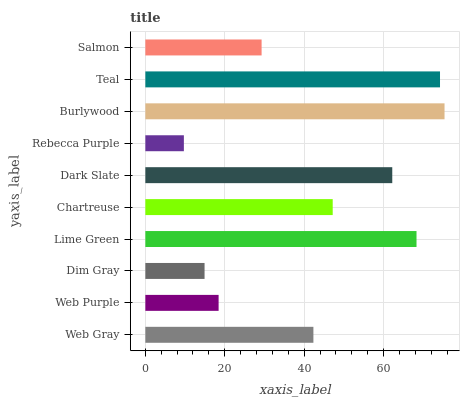Is Rebecca Purple the minimum?
Answer yes or no. Yes. Is Burlywood the maximum?
Answer yes or no. Yes. Is Web Purple the minimum?
Answer yes or no. No. Is Web Purple the maximum?
Answer yes or no. No. Is Web Gray greater than Web Purple?
Answer yes or no. Yes. Is Web Purple less than Web Gray?
Answer yes or no. Yes. Is Web Purple greater than Web Gray?
Answer yes or no. No. Is Web Gray less than Web Purple?
Answer yes or no. No. Is Chartreuse the high median?
Answer yes or no. Yes. Is Web Gray the low median?
Answer yes or no. Yes. Is Dark Slate the high median?
Answer yes or no. No. Is Salmon the low median?
Answer yes or no. No. 